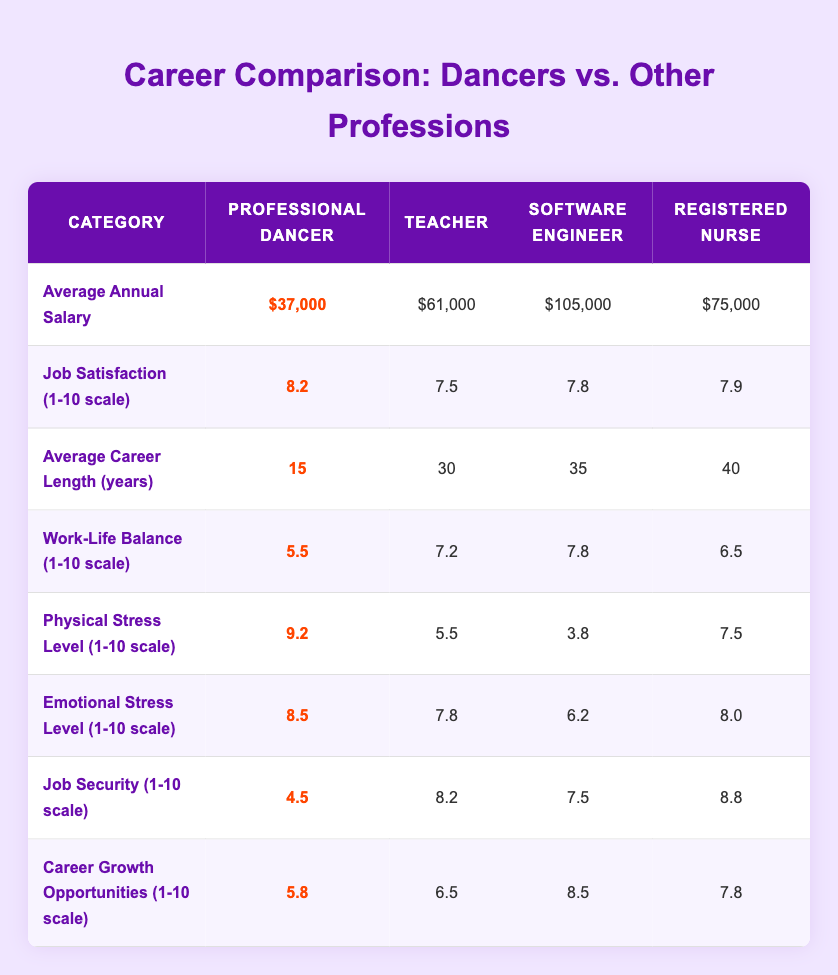What is the average annual salary of a professional dancer? The table clearly shows the average annual salary for a professional dancer as $37,000.
Answer: $37,000 How does the job satisfaction of professional dancers compare to teachers? The job satisfaction for professional dancers is 8.2, while for teachers it is 7.5. Thus, professional dancers have higher job satisfaction by 0.7.
Answer: 0.7 What is the difference in average career length between professional dancers and registered nurses? According to the table, the average career length for professional dancers is 15 years and for registered nurses, it is 40 years. The difference is 40 - 15 = 25 years.
Answer: 25 years Is the physical stress level higher for professional dancers or software engineers? The physical stress level for professional dancers is 9.2, while for software engineers it is 3.8. Since 9.2 is greater than 3.8, professional dancers experience higher physical stress.
Answer: Yes What overall trend can be observed regarding job security among the listed professions? Examining the job security scores: professional dancers 4.5, teachers 8.2, software engineers 7.5, and registered nurses 8.8, it shows that professional dancers have the lowest job security compared to all other professions listed. This indicates a trend of lower job security for dancers.
Answer: Lower job security for dancers What is the overall average score for career growth opportunities among the professions listed? To calculate the overall average for career growth opportunities, add the scores: 5.8 (dancers) + 6.5 (teachers) + 8.5 (software engineers) + 7.8 (nurses) = 28.6. Then divide by the number of professions: 28.6 / 4 = 7.15.
Answer: 7.15 